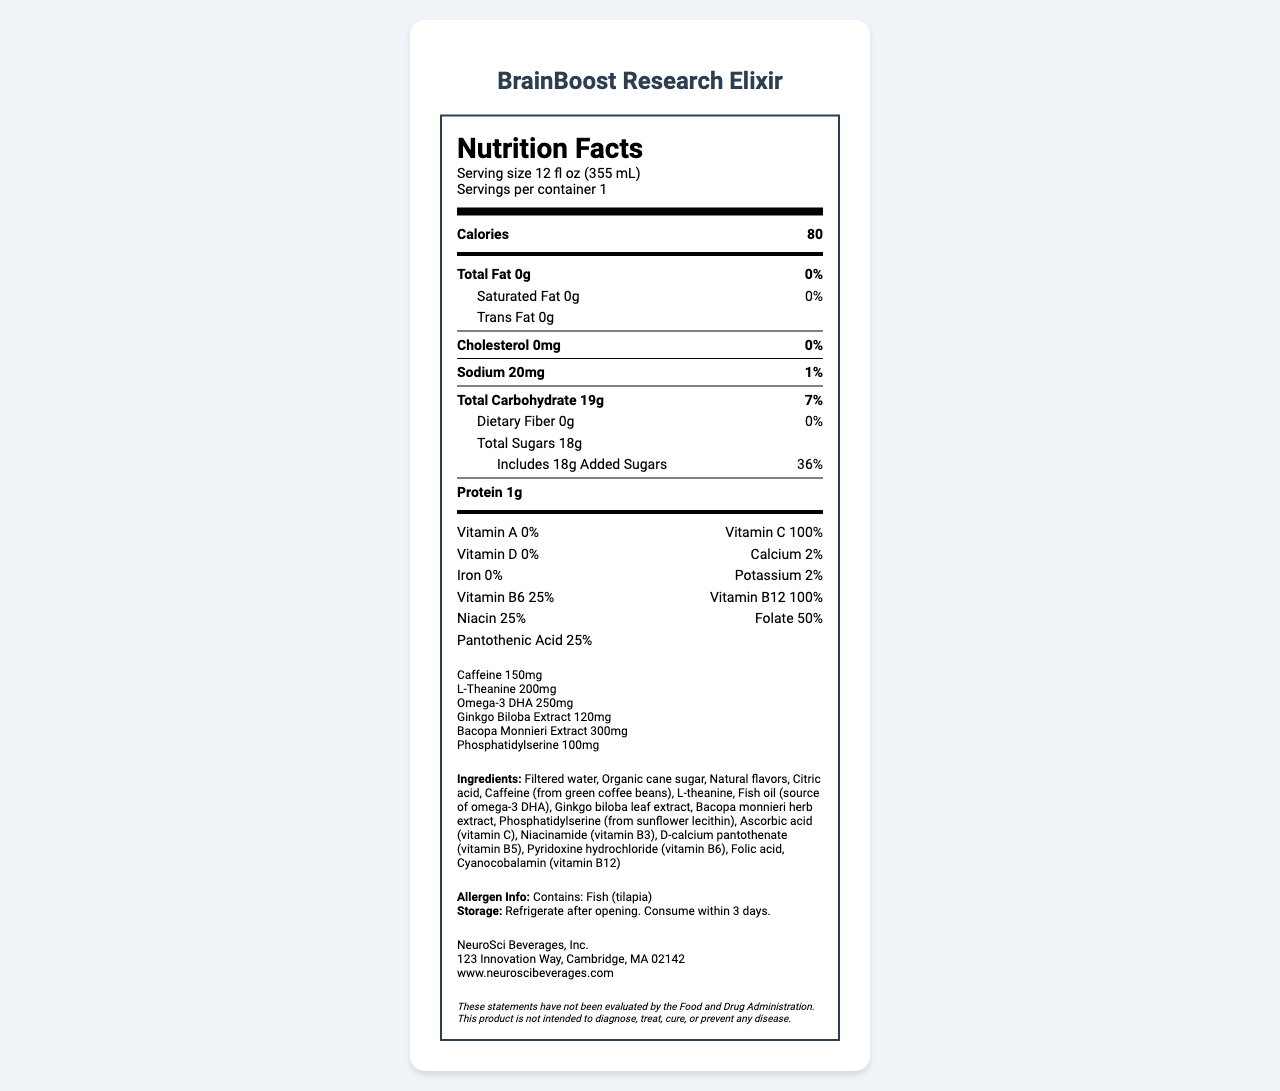what is the name of the product? The label at the top clearly states that the product's name is "BrainBoost Research Elixir".
Answer: BrainBoost Research Elixir how many calories are in one serving? The Nutrition Facts section lists the amount of calories as 80.
Answer: 80 what is the serving size? The serving size is indicated as 12 fl oz (355 mL) under the serving information section.
Answer: 12 fl oz (355 mL) how much sodium is in the beverage? The sodium content is listed in the Nutrition Facts under the nutrients, showing 20mg.
Answer: 20mg what is the amount of total sugars in the product? The total sugars content is listed as 18g in the Nutrition Facts section.
Answer: 18g what percentage of the daily value for vitamin C does the product provide? The Nutrition Facts section lists Vitamin C with 100% daily value.
Answer: 100% which vitamin is completely absent in the product? A. Vitamin A B. Vitamin C C. Vitamin D D. Vitamin B12 Vitamin A is listed as 0% in the Nutrition Facts, indicating it is absent.
Answer: A how much caffeine is in the beverage? A. 100mg B. 150mg C. 200mg D. 250mg The additional information section lists caffeine content as 150mg.
Answer: B does the product contain any allergens? Yes/No The allergen information section notes that the product contains fish (tilapia).
Answer: Yes summarize the main purpose of this document. The document provides various pieces of information about the product, including its name, serving size, number of calories, amounts of various nutrients, presence of specific ingredients, and special instructions for storage and allergies. The intended use of the beverage is also highlighted.
Answer: The document is a Nutrition Facts label for BrainBoost Research Elixir, detailing its nutritional content, ingredients, allergens, storage instructions, and contact information. The beverage is designed to support cognitive function during long research hours. how much protein does the product contain? The Nutrition Facts section lists the protein content as 1g.
Answer: 1g which ingredient is the primary source of omega-3 DHA? The ingredients section lists fish oil as the source of omega-3 DHA.
Answer: Fish oil how many nutrients have a daily value percentage greater than 25%? Vitamin C, Vitamin B12, Folate, and Pantothenic Acid each have daily value percentages greater than 25%.
Answer: Four how many servings are there per container? The serving information section states that there is 1 serving per container.
Answer: 1 how much L-Theanine does the beverage contain? The additional information section lists L-Theanine content as 200mg.
Answer: 200mg where is the product manufactured? The address of the manufacturer is provided in the additional information section.
Answer: 123 Innovation Way, Cambridge, MA 02142 how should the product be stored? The storage instructions specify refrigeration after opening and consumption within 3 days.
Answer: Refrigerate after opening. Consume within 3 days. does the product contribute to the daily value of iron? The Nutrition Facts section lists iron at 0%, indicating no contribution to the daily value.
Answer: No what is the concentration of Bacopa Monnieri Extract in the product? The additional information section lists Bacopa Monnieri Extract content as 300mg.
Answer: 300mg can we determine how many cups of coffee this product is equivalent to in terms of caffeine? The document does not provide any information about the caffeine content of a cup of coffee, so we cannot make this comparison.
Answer: Cannot be determined how much phosphatidylserine is in the beverage? The additional information section lists phosphatidylserine content as 100mg.
Answer: 100mg 